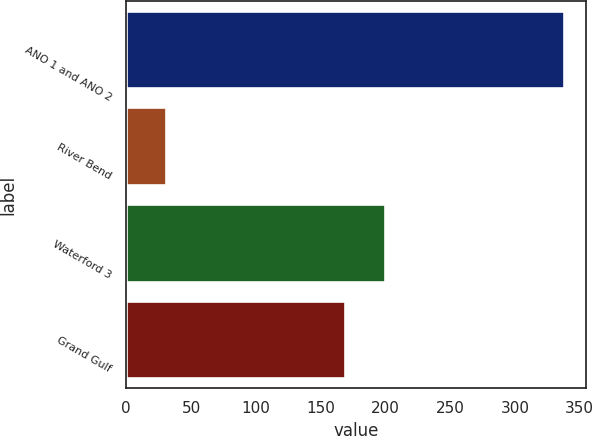Convert chart. <chart><loc_0><loc_0><loc_500><loc_500><bar_chart><fcel>ANO 1 and ANO 2<fcel>River Bend<fcel>Waterford 3<fcel>Grand Gulf<nl><fcel>337.9<fcel>30.6<fcel>199.83<fcel>169.1<nl></chart> 